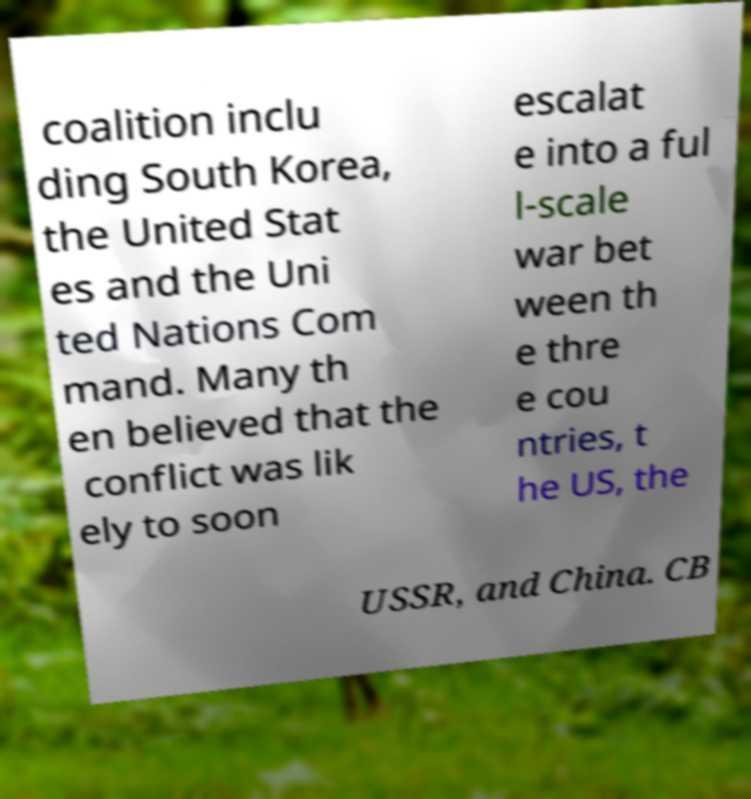Can you read and provide the text displayed in the image?This photo seems to have some interesting text. Can you extract and type it out for me? coalition inclu ding South Korea, the United Stat es and the Uni ted Nations Com mand. Many th en believed that the conflict was lik ely to soon escalat e into a ful l-scale war bet ween th e thre e cou ntries, t he US, the USSR, and China. CB 